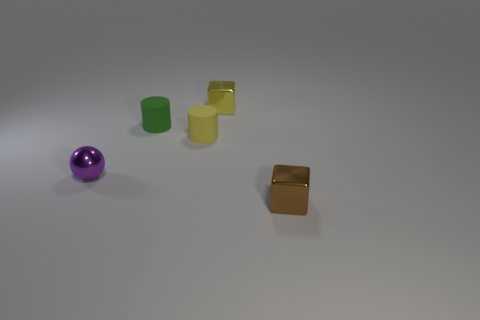Subtract 1 cylinders. How many cylinders are left? 1 Subtract all green blocks. Subtract all blue spheres. How many blocks are left? 2 Subtract all cyan spheres. How many yellow blocks are left? 1 Subtract all brown shiny objects. Subtract all tiny yellow blocks. How many objects are left? 3 Add 1 purple balls. How many purple balls are left? 2 Add 2 large green cubes. How many large green cubes exist? 2 Add 5 big purple metallic cylinders. How many objects exist? 10 Subtract 0 blue spheres. How many objects are left? 5 Subtract all cubes. How many objects are left? 3 